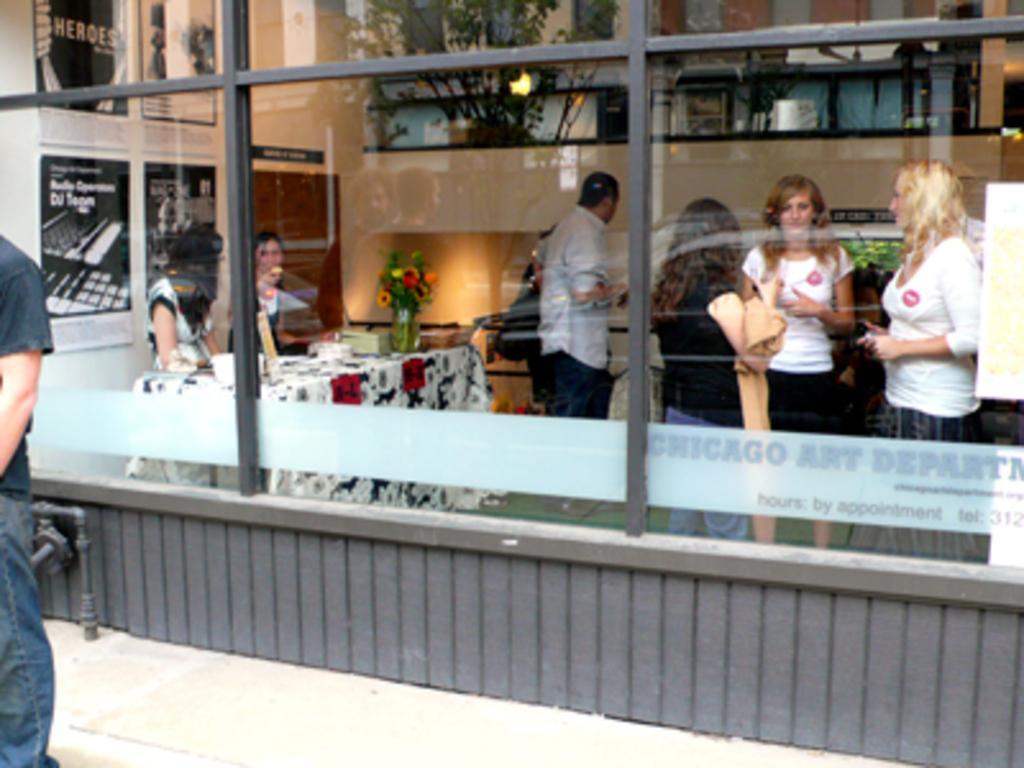Please provide a concise description of this image. In the picture we can see a glass wall with a rod frame and outside it, we can see a person standing and inside we can see a table with tablecloth and a flower vase on it with some flowers and two women are standing near it and some people are standing and talking and in the background we can see a wall with some photo frames and some plant. 